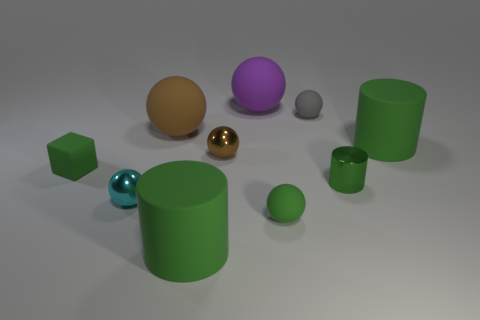What is the texture and color of the objects in the middle of the scene? The objects in the middle of the scene consist of a glossy turquoise sphere and a shiny gold sphere. The turquoise sphere has a smooth and reflective surface allowing light to create highlights and subtle reflections. The gold sphere also has a polished surface, with a metallic sheen that gives it a brilliant, reflective appearance. Color-wise, the turquoise is a blend of blue and green, bright and vibrant, while the gold has a rich, lustrous yellow hue, akin to the precious metal it's named after. 